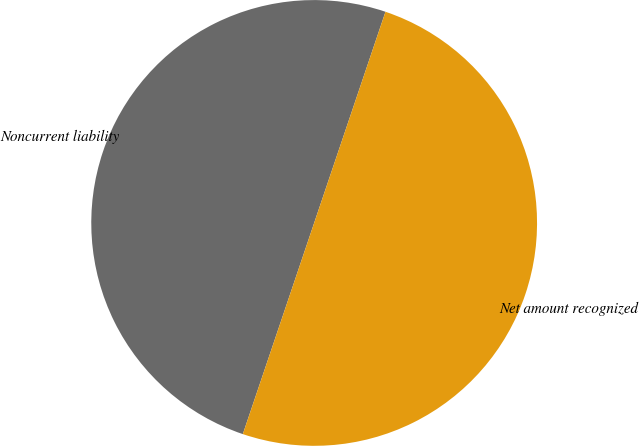<chart> <loc_0><loc_0><loc_500><loc_500><pie_chart><fcel>Noncurrent liability<fcel>Net amount recognized<nl><fcel>50.0%<fcel>50.0%<nl></chart> 